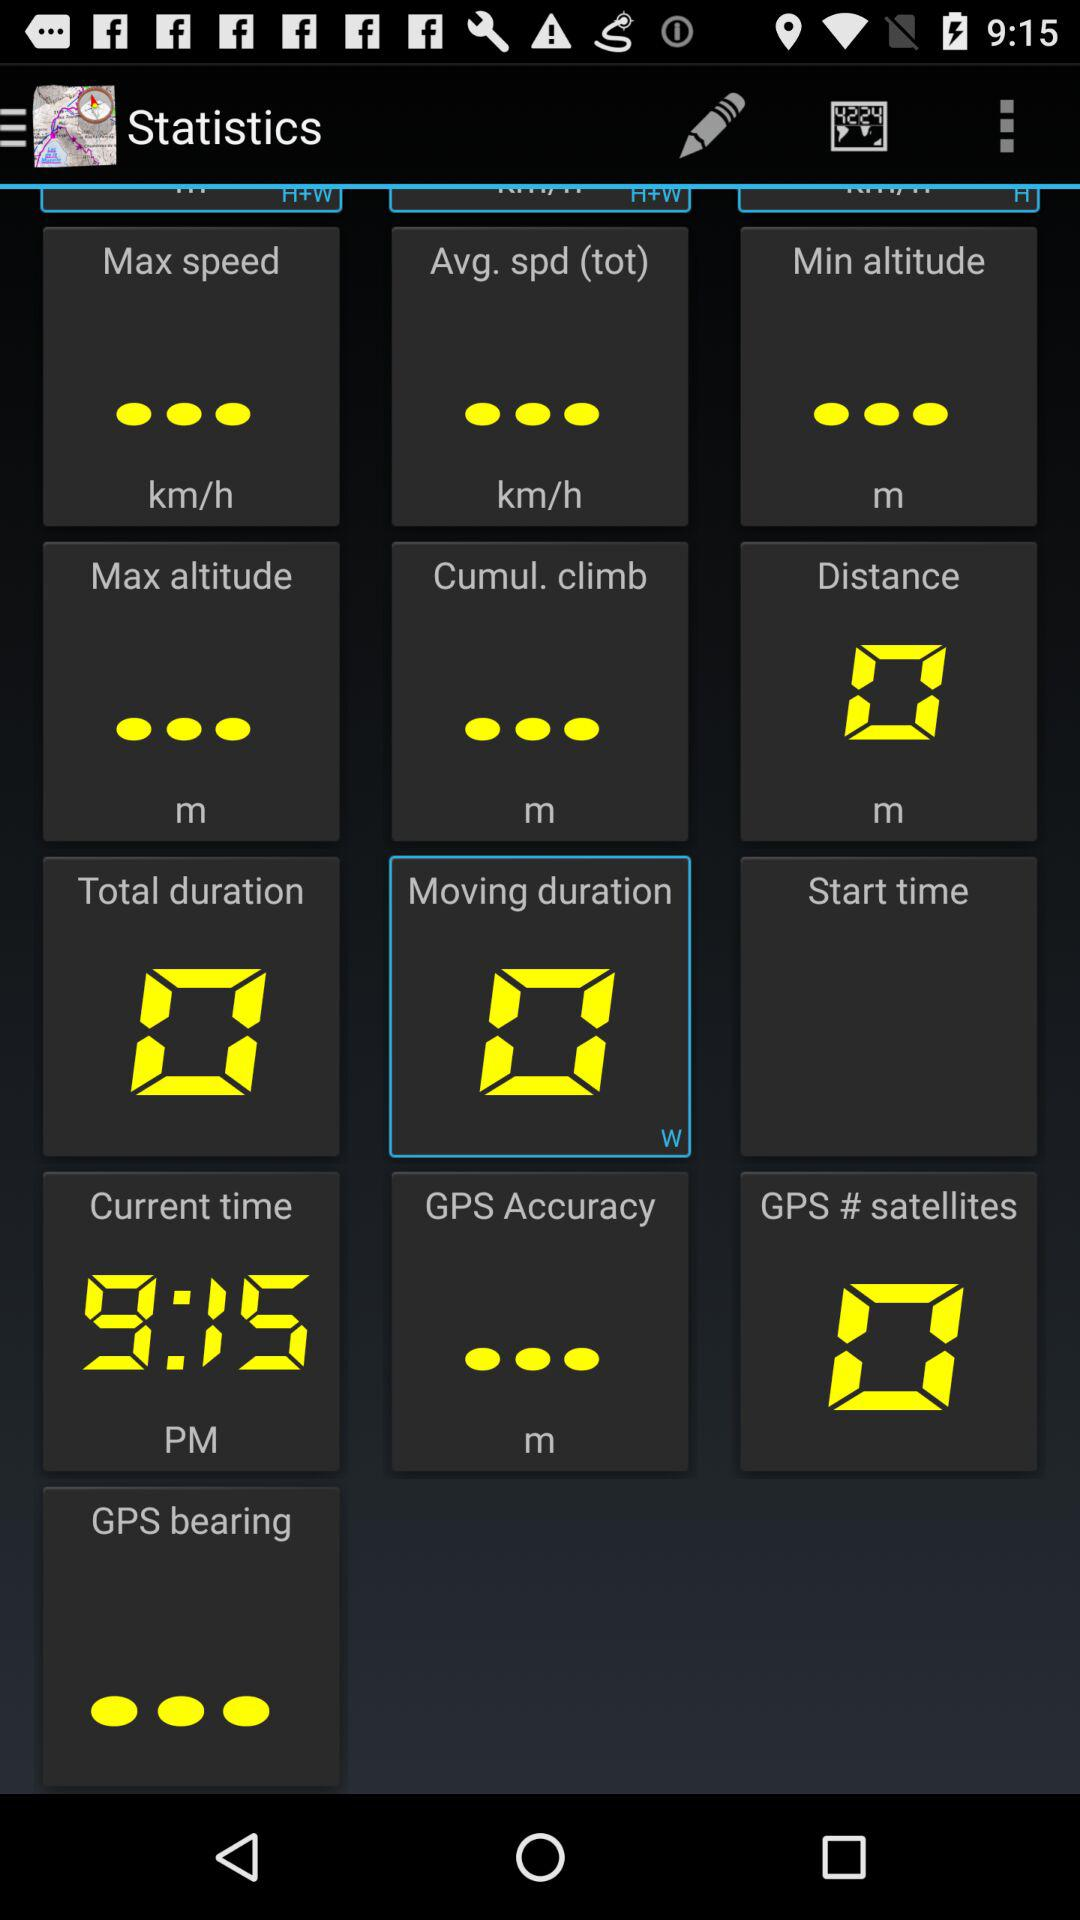What is the current time? The current time is 9:15 PM. 